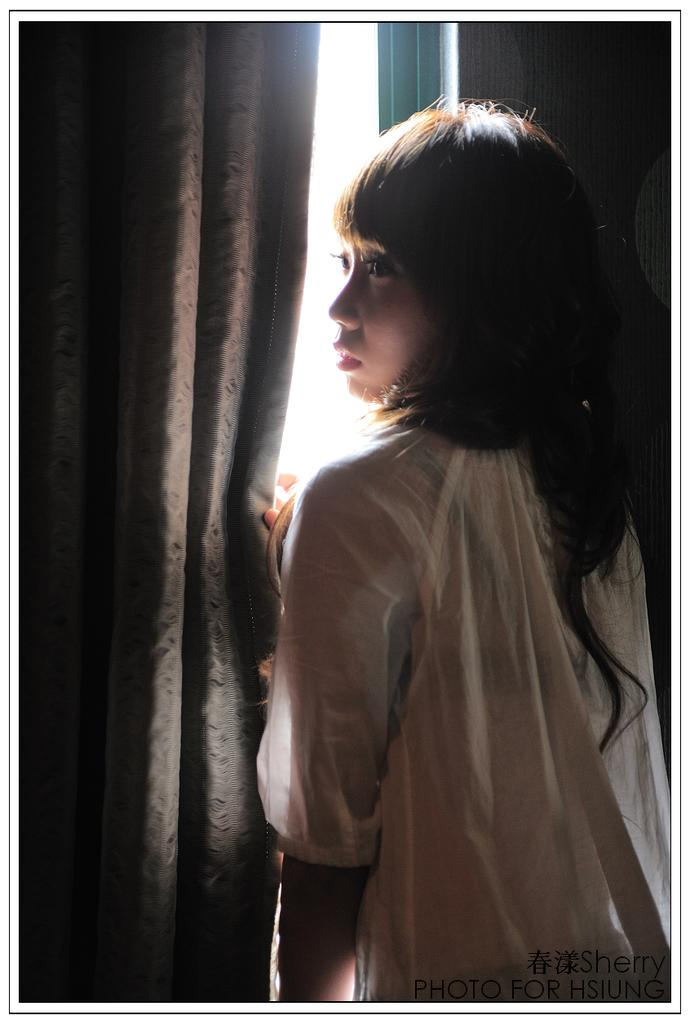Who is present in the image? There is a woman in the image. What is behind the woman in the image? The woman is in front of a curtain. Is there any text visible in the image? Yes, there is text visible at the bottom of the image. How many tomatoes are on the woman's mouth in the image? There are no tomatoes or mouth visible in the image; it only features a woman in front of a curtain with text at the bottom. 